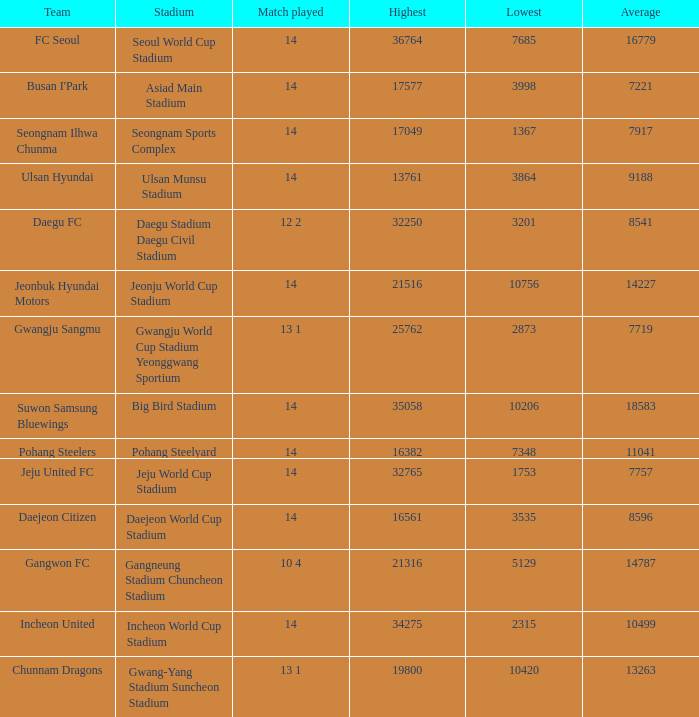Which team has 7757 as the average? Jeju United FC. 